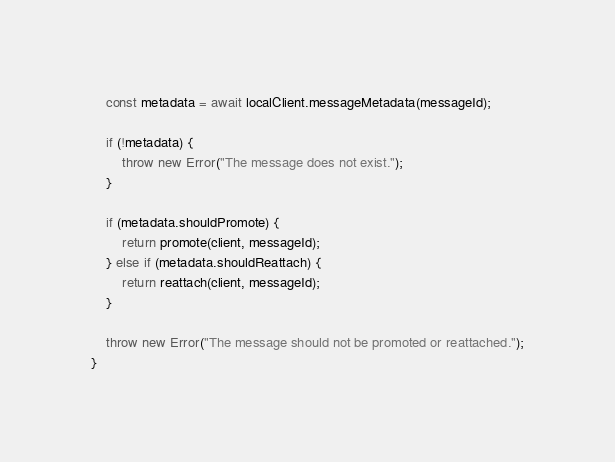Convert code to text. <code><loc_0><loc_0><loc_500><loc_500><_TypeScript_>
    const metadata = await localClient.messageMetadata(messageId);

    if (!metadata) {
        throw new Error("The message does not exist.");
    }

    if (metadata.shouldPromote) {
        return promote(client, messageId);
    } else if (metadata.shouldReattach) {
        return reattach(client, messageId);
    }

    throw new Error("The message should not be promoted or reattached.");
}
</code> 